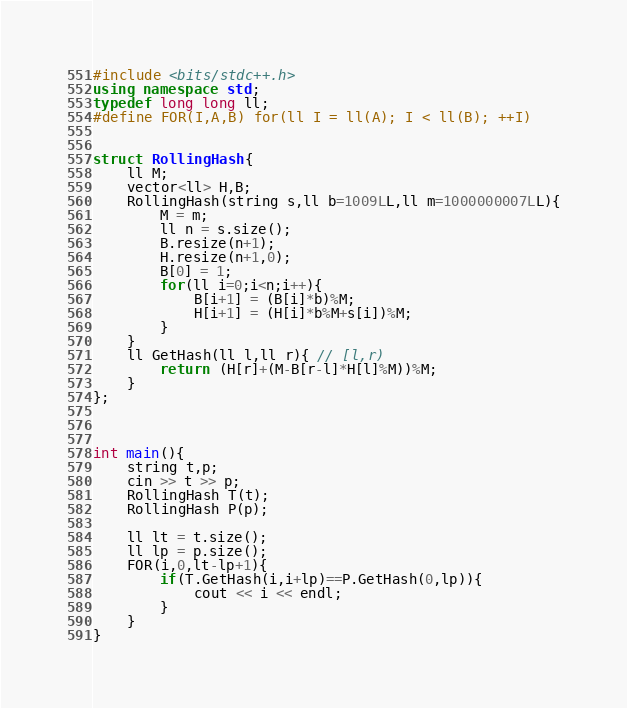<code> <loc_0><loc_0><loc_500><loc_500><_C++_>#include <bits/stdc++.h>
using namespace std;
typedef long long ll;
#define FOR(I,A,B) for(ll I = ll(A); I < ll(B); ++I)
 

struct RollingHash{
	ll M;
	vector<ll> H,B;
	RollingHash(string s,ll b=1009LL,ll m=1000000007LL){
		M = m;
		ll n = s.size();
		B.resize(n+1);
		H.resize(n+1,0);
		B[0] = 1;
		for(ll i=0;i<n;i++){
			B[i+1] = (B[i]*b)%M;
			H[i+1] = (H[i]*b%M+s[i])%M;
		}
	}
	ll GetHash(ll l,ll r){ // [l,r)
		return (H[r]+(M-B[r-l]*H[l]%M))%M;
	}
};


 
int main(){
	string t,p;
	cin >> t >> p;
	RollingHash T(t);
	RollingHash P(p);

	ll lt = t.size();
	ll lp = p.size();
	FOR(i,0,lt-lp+1){
		if(T.GetHash(i,i+lp)==P.GetHash(0,lp)){
			cout << i << endl;
		}
	}
}
</code> 